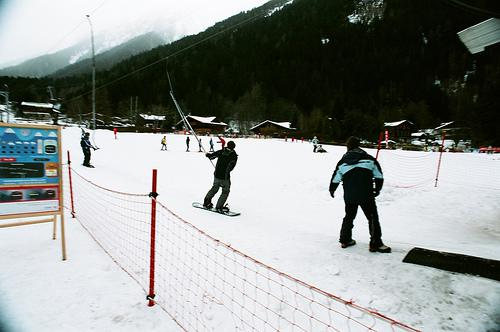Question: what sport are these people doing?
Choices:
A. Sking.
B. Surfing.
C. Snowboarding.
D. Tennis.
Answer with the letter. Answer: C Question: how many people are near the fence?
Choices:
A. Three.
B. Two.
C. One.
D. Four.
Answer with the letter. Answer: A Question: who is this a picture of?
Choices:
A. Skiers.
B. Surfers.
C. Snowboarders.
D. Tennis players.
Answer with the letter. Answer: C Question: what season was this picture taken in?
Choices:
A. Spring.
B. Summer.
C. Fall.
D. Winter.
Answer with the letter. Answer: D 